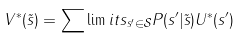<formula> <loc_0><loc_0><loc_500><loc_500>V ^ { * } ( \tilde { s } ) = \sum \lim i t s _ { s ^ { \prime } \in \mathcal { S } } P ( s ^ { \prime } | \tilde { s } ) U ^ { * } ( s ^ { \prime } )</formula> 